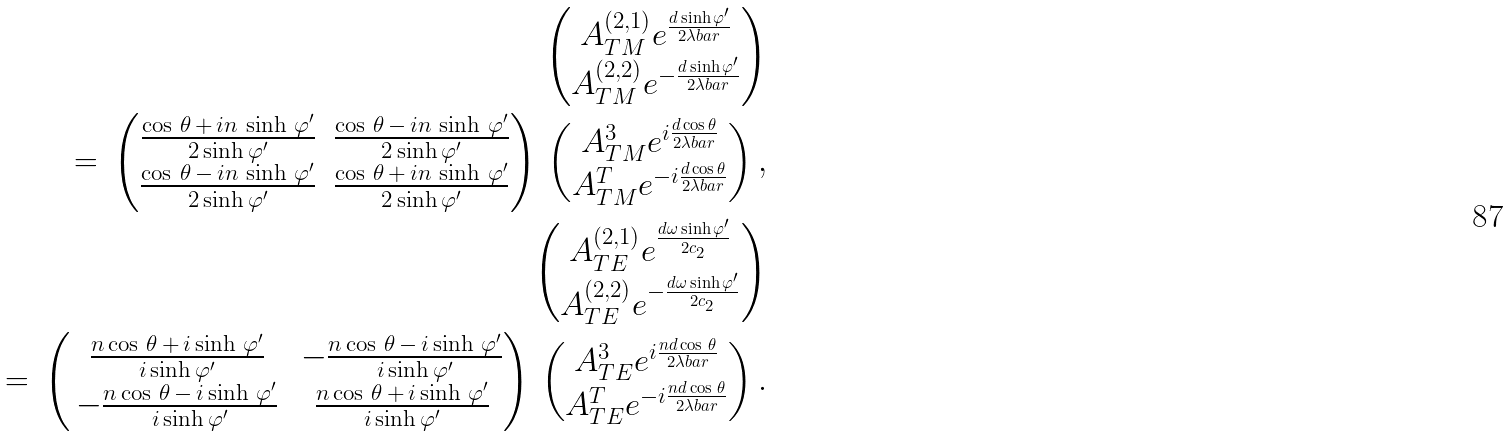<formula> <loc_0><loc_0><loc_500><loc_500>\begin{pmatrix} A ^ { ( 2 , 1 ) } _ { T M } e ^ { \frac { d \sinh \varphi ^ { \prime } } { 2 \lambda b a r } } \\ A ^ { ( 2 , 2 ) } _ { T M } e ^ { - \frac { d \sinh \varphi ^ { \prime } } { 2 \lambda b a r } } \end{pmatrix} \\ = \, \begin{pmatrix} \frac { \cos \, \theta \, + \, i n \, \sinh \, \varphi ^ { \prime } } { 2 \sinh \varphi ^ { \prime } } & \frac { \cos \, \theta \, - \, i n \, \sinh \, \varphi ^ { \prime } } { 2 \sinh \varphi ^ { \prime } } \\ \frac { \cos \, \theta \, - \, i n \, \sinh \, \varphi ^ { \prime } } { 2 \sinh \varphi ^ { \prime } } & \frac { \cos \, \theta \, + \, i n \, \sinh \, \varphi ^ { \prime } } { 2 \sinh \varphi ^ { \prime } } \end{pmatrix} \, \begin{pmatrix} A ^ { 3 } _ { T M } e ^ { i \frac { d \cos \theta } { 2 \lambda b a r } } \\ A ^ { T } _ { T M } e ^ { - i \frac { d \cos \theta } { 2 \lambda b a r } } \end{pmatrix} , \\ \begin{pmatrix} A ^ { ( 2 , 1 ) } _ { T E } e ^ { \frac { d \omega \sinh \varphi ^ { \prime } } { 2 c _ { 2 } } } \\ A ^ { ( 2 , 2 ) } _ { T E } e ^ { - \frac { d \omega \sinh \varphi ^ { \prime } } { 2 c _ { 2 } } } \end{pmatrix} \\ = \, \begin{pmatrix} \, \frac { n \cos \, \theta \, + \, i \sinh \, \varphi ^ { \prime } } { i \sinh \varphi ^ { \prime } } & \, - \frac { n \cos \, \theta \, - \, i \sinh \, \varphi ^ { \prime } } { i \sinh \varphi ^ { \prime } } \\ \, - \frac { n \cos \, \theta \, - \, i \sinh \, \varphi ^ { \prime } } { i \sinh \varphi ^ { \prime } } & \, \frac { n \cos \, \theta \, + \, i \sinh \, \varphi ^ { \prime } } { i \sinh \varphi ^ { \prime } } \end{pmatrix} \, \begin{pmatrix} A ^ { 3 } _ { T E } e ^ { i \frac { n d \cos \, \theta } { 2 \lambda b a r } } \\ A ^ { T } _ { T E } e ^ { - i \frac { n d \cos \, \theta } { 2 \lambda b a r } } \end{pmatrix} .</formula> 